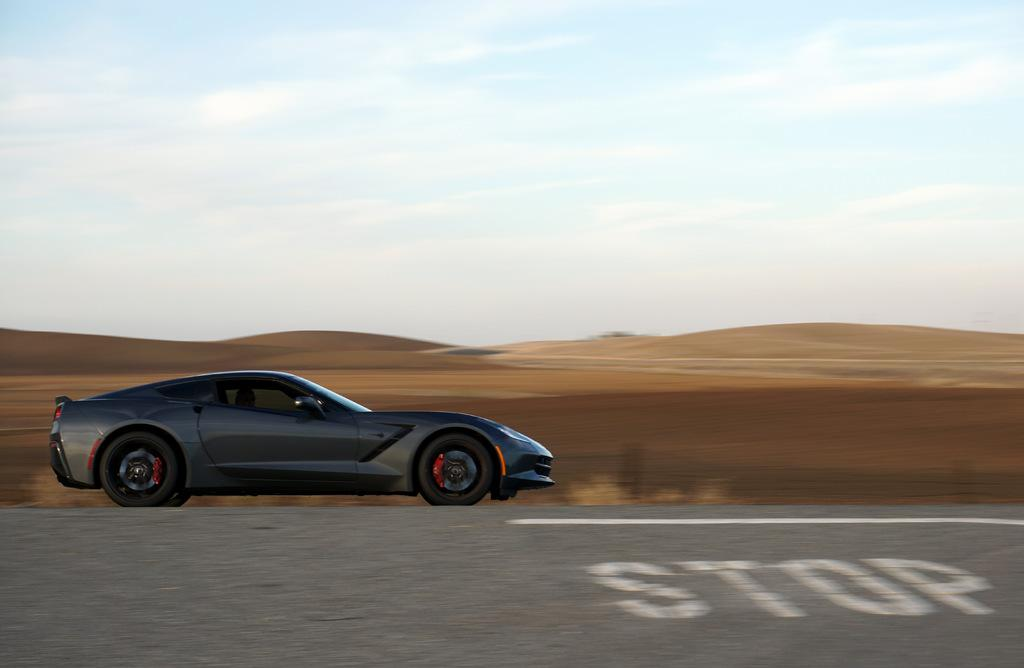What is the main subject of the image? The main subject of the image is a car. Where is the car located in the image? The car is on the road in the image. What can be seen in the background of the image? There is sand and the sky visible in the background of the image. Can you tell me how many geese are flying in the image? There are no geese present in the image; it features a car on the road with sand and the sky visible in the background. 